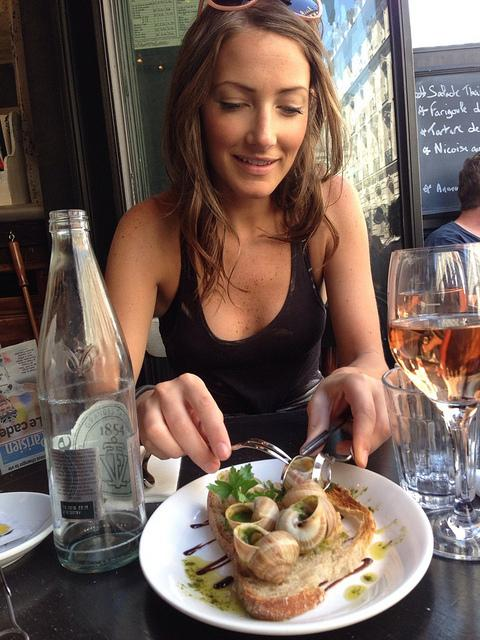What country are they in?

Choices:
A) france
B) portugal
C) england
D) spain france 